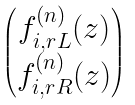<formula> <loc_0><loc_0><loc_500><loc_500>\begin{pmatrix} f _ { i , r L } ^ { ( n ) } ( z ) \\ f _ { i , r R } ^ { ( n ) } ( z ) \end{pmatrix}</formula> 